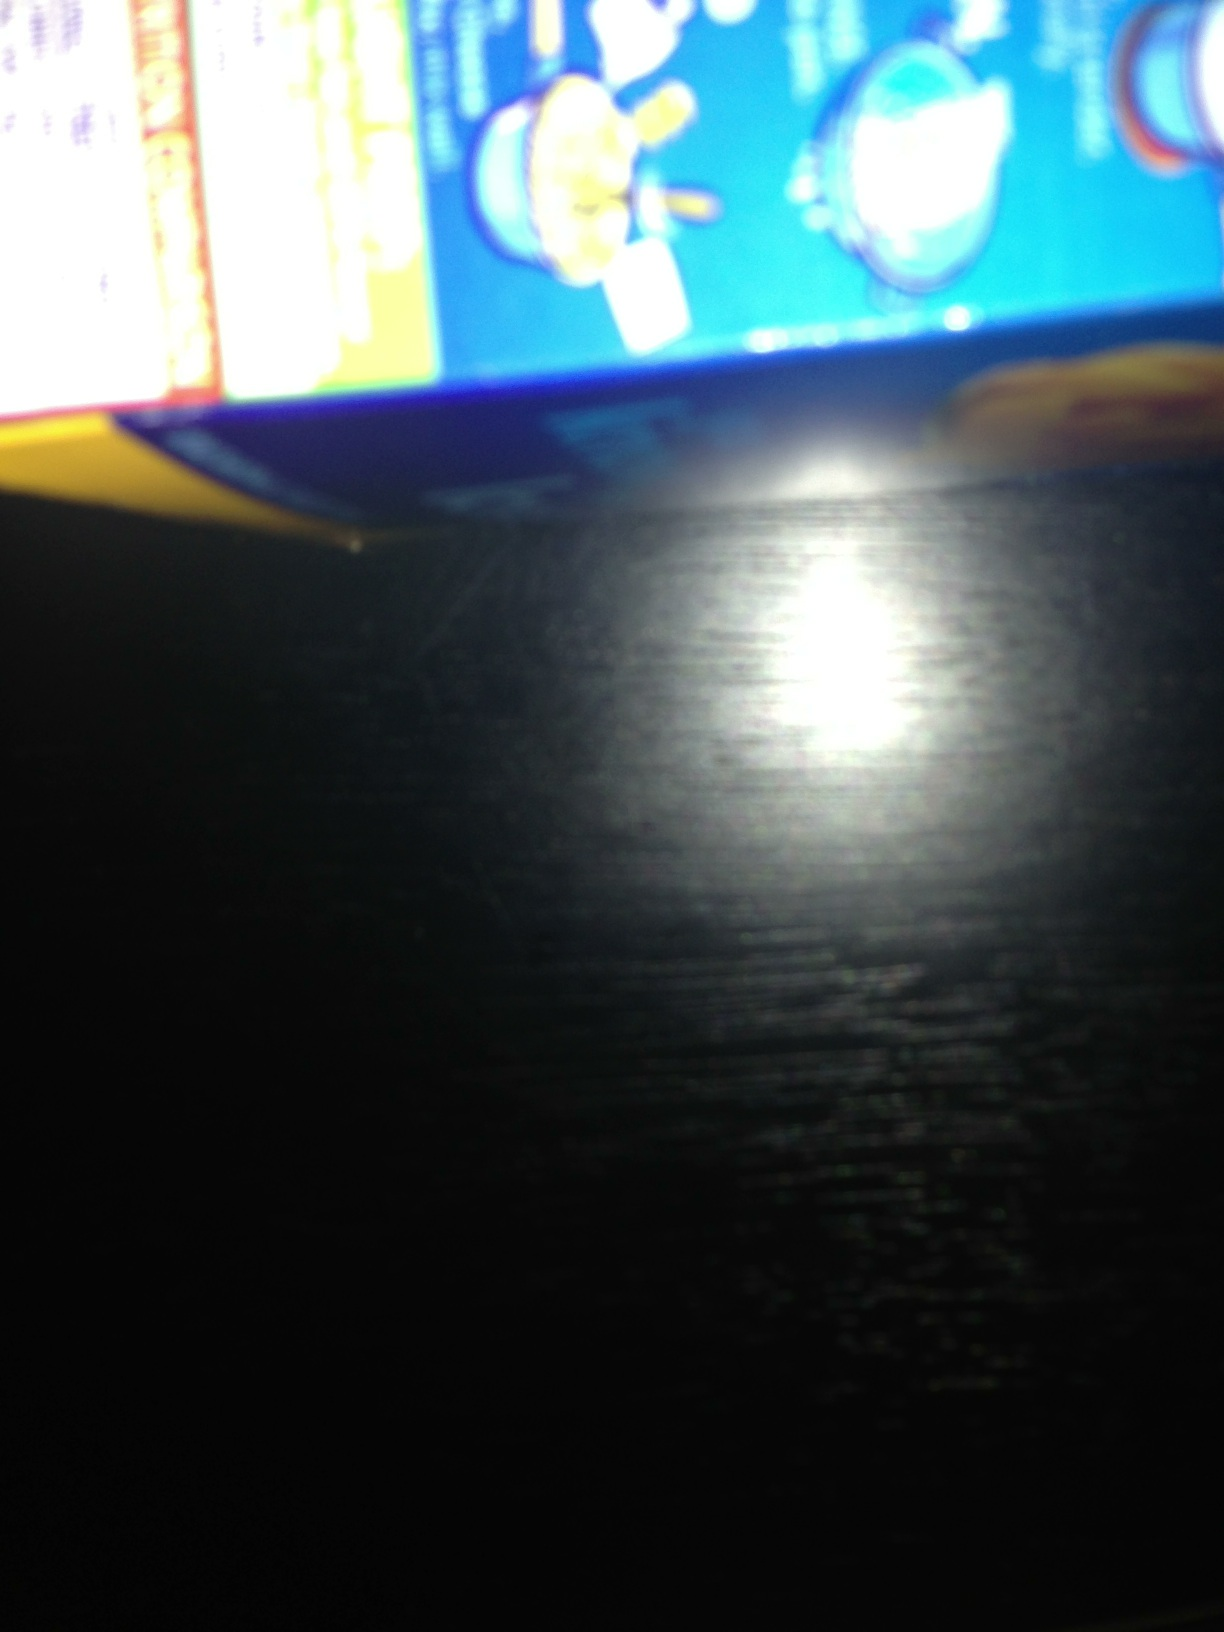Could you tell me the cooking instructions on this box, please? And if not, tell me how to guide my camera. The image is blurry and the text is not entirely readable. To capture a clearer image, ensure the box is well-lit and hold the camera steady. You may also want to switch to a high-resolution mode on your camera, ensuring it is properly focused before taking the picture. 